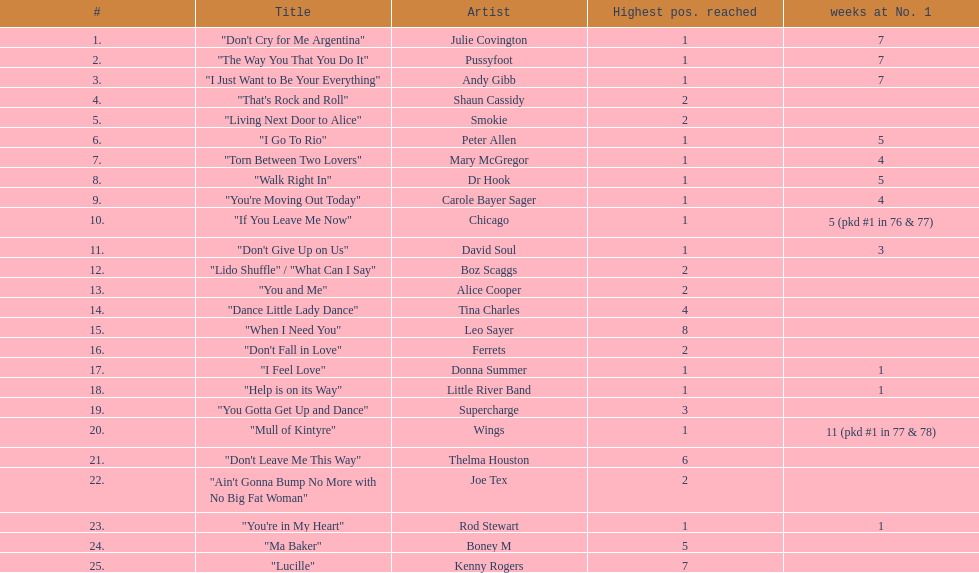According to the table, who held the number one position for the most weeks? Wings. 